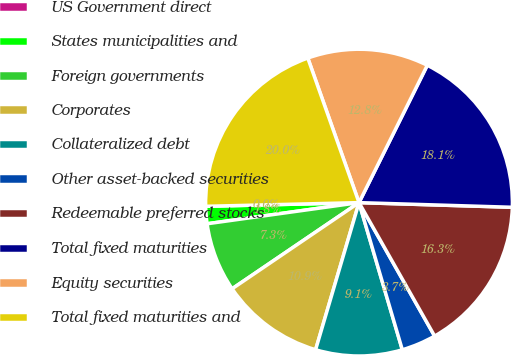Convert chart. <chart><loc_0><loc_0><loc_500><loc_500><pie_chart><fcel>US Government direct<fcel>States municipalities and<fcel>Foreign governments<fcel>Corporates<fcel>Collateralized debt<fcel>Other asset-backed securities<fcel>Redeemable preferred stocks<fcel>Total fixed maturities<fcel>Equity securities<fcel>Total fixed maturities and<nl><fcel>0.0%<fcel>1.82%<fcel>7.29%<fcel>10.94%<fcel>9.12%<fcel>3.65%<fcel>16.31%<fcel>18.14%<fcel>12.76%<fcel>19.96%<nl></chart> 